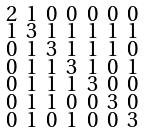<formula> <loc_0><loc_0><loc_500><loc_500>\begin{smallmatrix} 2 & 1 & 0 & 0 & 0 & 0 & 0 \\ 1 & 3 & 1 & 1 & 1 & 1 & 1 \\ 0 & 1 & 3 & 1 & 1 & 1 & 0 \\ 0 & 1 & 1 & 3 & 1 & 0 & 1 \\ 0 & 1 & 1 & 1 & 3 & 0 & 0 \\ 0 & 1 & 1 & 0 & 0 & 3 & 0 \\ 0 & 1 & 0 & 1 & 0 & 0 & 3 \end{smallmatrix}</formula> 